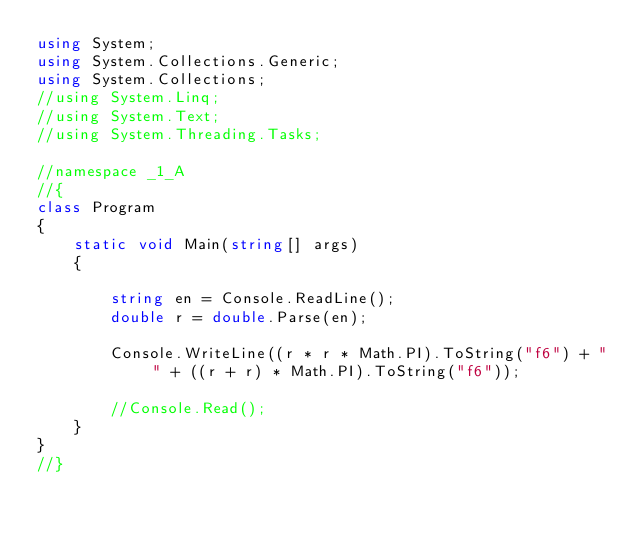Convert code to text. <code><loc_0><loc_0><loc_500><loc_500><_C#_>using System;
using System.Collections.Generic;
using System.Collections;
//using System.Linq;
//using System.Text;
//using System.Threading.Tasks;

//namespace _1_A
//{
class Program
{
    static void Main(string[] args)
    {

        string en = Console.ReadLine();
        double r = double.Parse(en);
        
        Console.WriteLine((r * r * Math.PI).ToString("f6") + " " + ((r + r) * Math.PI).ToString("f6"));

        //Console.Read();
    }
}
//}</code> 